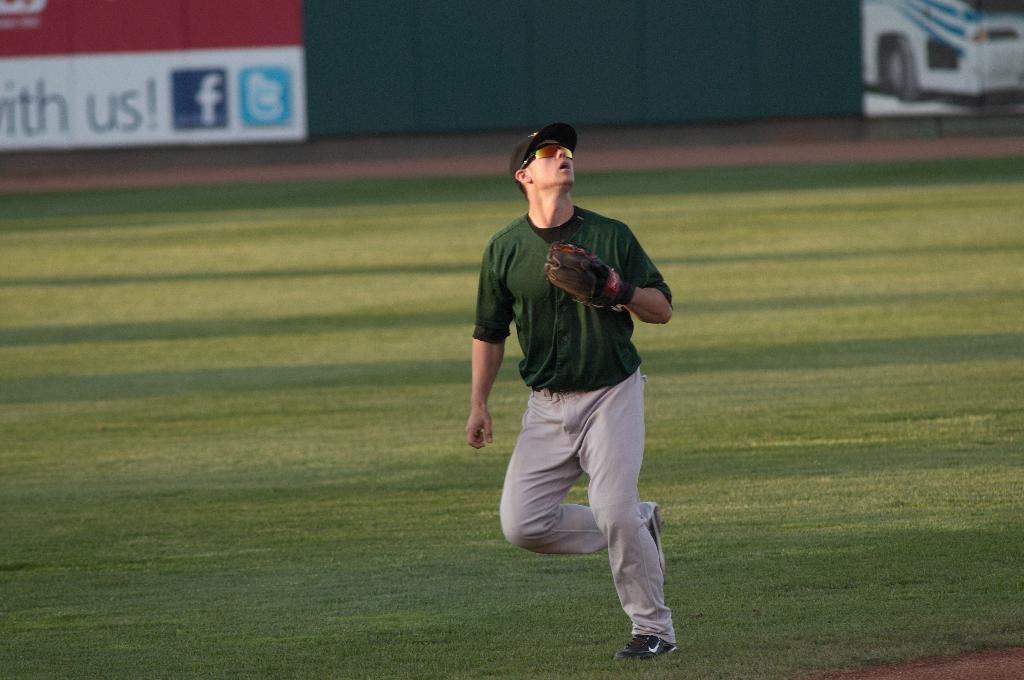<image>
Give a short and clear explanation of the subsequent image. a person trying to catch a ball with the word us behind him 